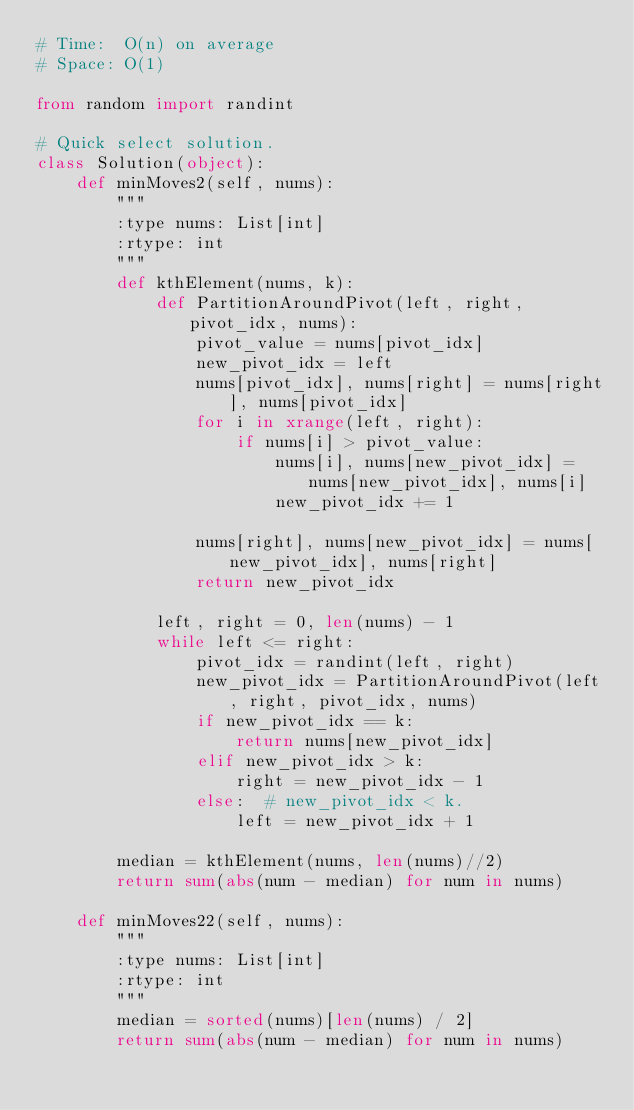Convert code to text. <code><loc_0><loc_0><loc_500><loc_500><_Python_># Time:  O(n) on average
# Space: O(1)

from random import randint

# Quick select solution.
class Solution(object):
    def minMoves2(self, nums):
        """
        :type nums: List[int]
        :rtype: int
        """
        def kthElement(nums, k):
            def PartitionAroundPivot(left, right, pivot_idx, nums):
                pivot_value = nums[pivot_idx]
                new_pivot_idx = left
                nums[pivot_idx], nums[right] = nums[right], nums[pivot_idx]
                for i in xrange(left, right):
                    if nums[i] > pivot_value:
                        nums[i], nums[new_pivot_idx] = nums[new_pivot_idx], nums[i]
                        new_pivot_idx += 1

                nums[right], nums[new_pivot_idx] = nums[new_pivot_idx], nums[right]
                return new_pivot_idx

            left, right = 0, len(nums) - 1
            while left <= right:
                pivot_idx = randint(left, right)
                new_pivot_idx = PartitionAroundPivot(left, right, pivot_idx, nums)
                if new_pivot_idx == k:
                    return nums[new_pivot_idx]
                elif new_pivot_idx > k:
                    right = new_pivot_idx - 1
                else:  # new_pivot_idx < k.
                    left = new_pivot_idx + 1

        median = kthElement(nums, len(nums)//2)
        return sum(abs(num - median) for num in nums)

    def minMoves22(self, nums):
        """
        :type nums: List[int]
        :rtype: int
        """
        median = sorted(nums)[len(nums) / 2]
        return sum(abs(num - median) for num in nums)
</code> 